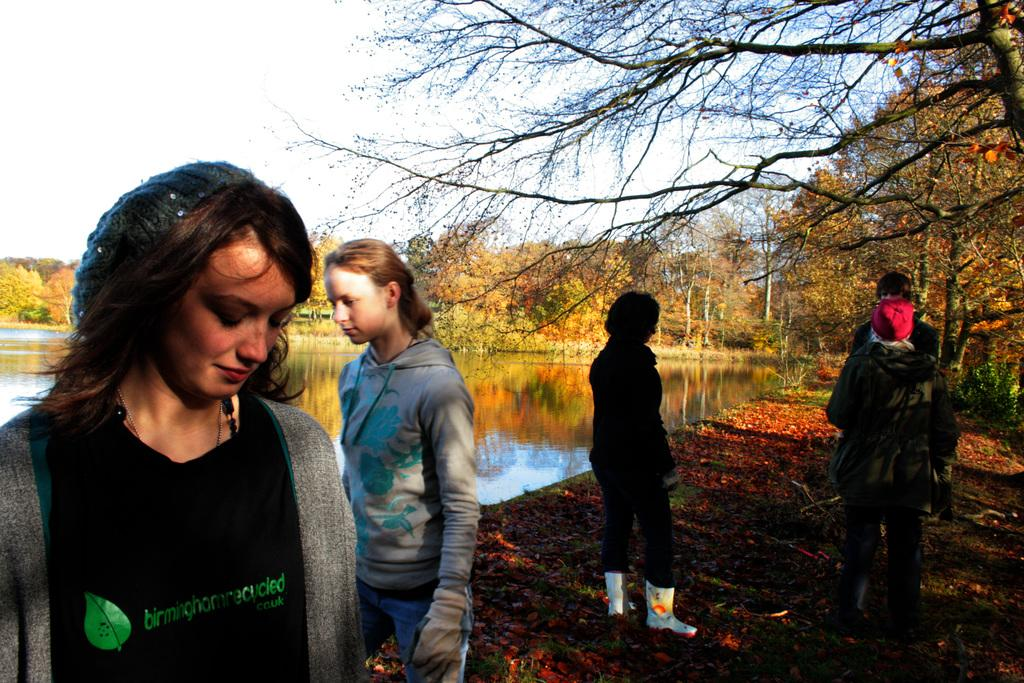What can be seen in the image involving people? There are people standing in the image. What natural feature is present in the image? There is a lake in the image. What type of vegetation is visible in the image? There are trees and plants in the image. Can you see a snake slithering through the plants in the image? There is no snake present in the image; only people, a lake, trees, and plants are visible. Is there any magic happening in the image? There is no indication of magic in the image; it depicts a natural scene with people, a lake, trees, and plants. 